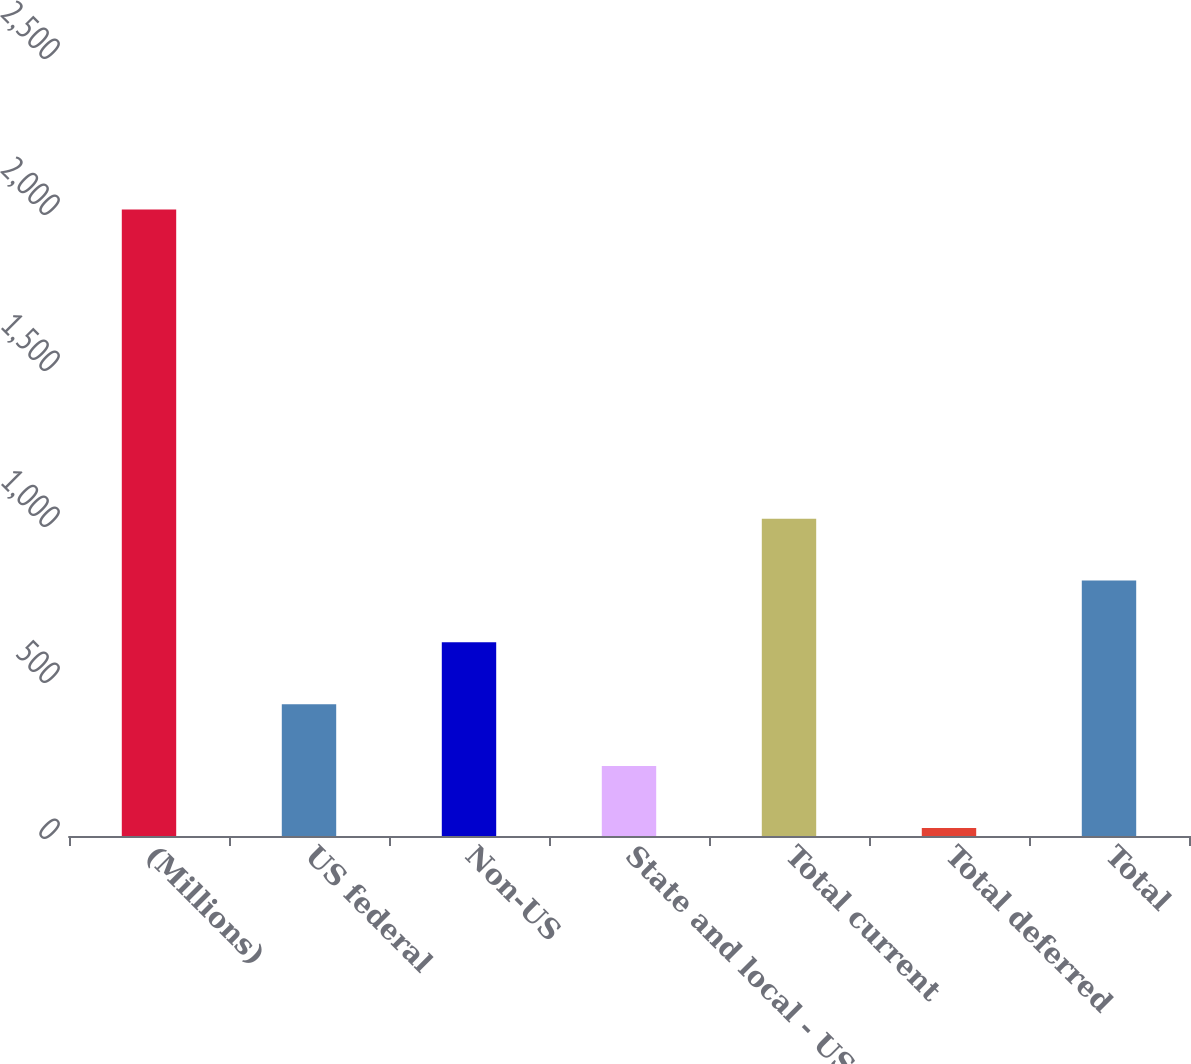Convert chart to OTSL. <chart><loc_0><loc_0><loc_500><loc_500><bar_chart><fcel>(Millions)<fcel>US federal<fcel>Non-US<fcel>State and local - US<fcel>Total current<fcel>Total deferred<fcel>Total<nl><fcel>2008<fcel>422.4<fcel>620.6<fcel>224.2<fcel>1017<fcel>26<fcel>818.8<nl></chart> 